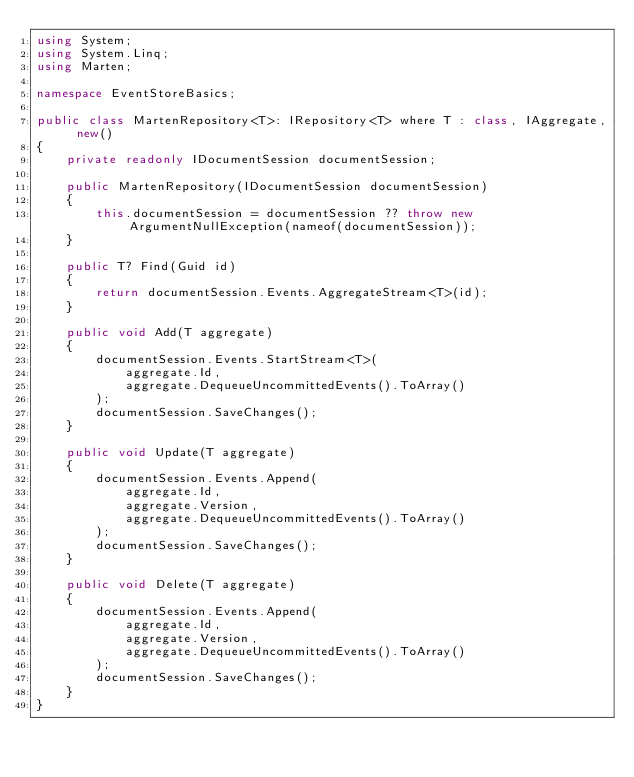<code> <loc_0><loc_0><loc_500><loc_500><_C#_>using System;
using System.Linq;
using Marten;

namespace EventStoreBasics;

public class MartenRepository<T>: IRepository<T> where T : class, IAggregate, new()
{
    private readonly IDocumentSession documentSession;

    public MartenRepository(IDocumentSession documentSession)
    {
        this.documentSession = documentSession ?? throw new ArgumentNullException(nameof(documentSession));
    }

    public T? Find(Guid id)
    {
        return documentSession.Events.AggregateStream<T>(id);
    }

    public void Add(T aggregate)
    {
        documentSession.Events.StartStream<T>(
            aggregate.Id,
            aggregate.DequeueUncommittedEvents().ToArray()
        );
        documentSession.SaveChanges();
    }

    public void Update(T aggregate)
    {
        documentSession.Events.Append(
            aggregate.Id,
            aggregate.Version,
            aggregate.DequeueUncommittedEvents().ToArray()
        );
        documentSession.SaveChanges();
    }

    public void Delete(T aggregate)
    {
        documentSession.Events.Append(
            aggregate.Id,
            aggregate.Version,
            aggregate.DequeueUncommittedEvents().ToArray()
        );
        documentSession.SaveChanges();
    }
}</code> 